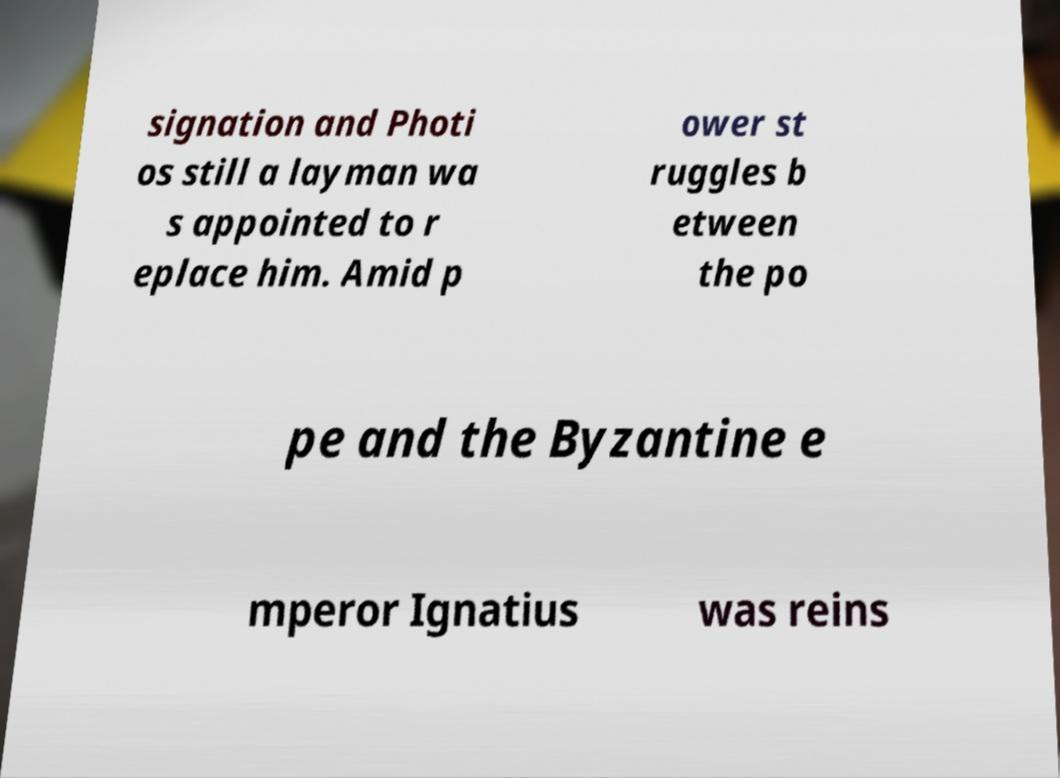For documentation purposes, I need the text within this image transcribed. Could you provide that? signation and Photi os still a layman wa s appointed to r eplace him. Amid p ower st ruggles b etween the po pe and the Byzantine e mperor Ignatius was reins 